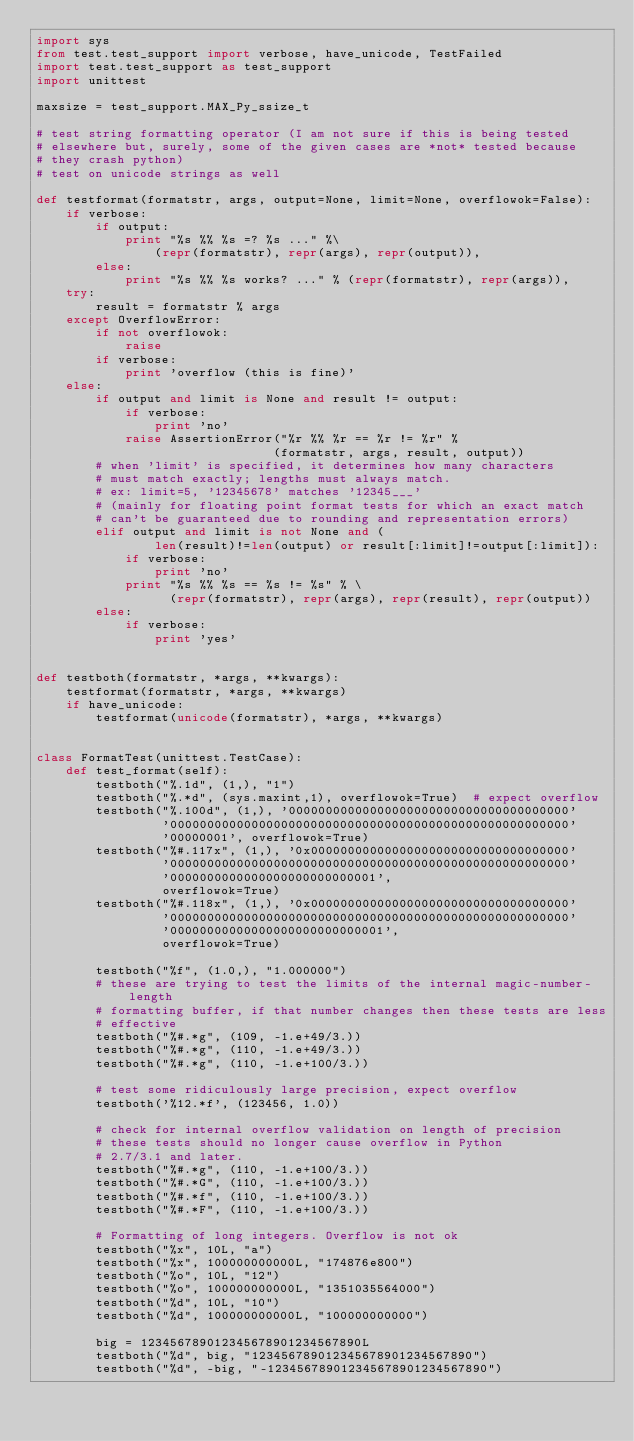Convert code to text. <code><loc_0><loc_0><loc_500><loc_500><_Python_>import sys
from test.test_support import verbose, have_unicode, TestFailed
import test.test_support as test_support
import unittest

maxsize = test_support.MAX_Py_ssize_t

# test string formatting operator (I am not sure if this is being tested
# elsewhere but, surely, some of the given cases are *not* tested because
# they crash python)
# test on unicode strings as well

def testformat(formatstr, args, output=None, limit=None, overflowok=False):
    if verbose:
        if output:
            print "%s %% %s =? %s ..." %\
                (repr(formatstr), repr(args), repr(output)),
        else:
            print "%s %% %s works? ..." % (repr(formatstr), repr(args)),
    try:
        result = formatstr % args
    except OverflowError:
        if not overflowok:
            raise
        if verbose:
            print 'overflow (this is fine)'
    else:
        if output and limit is None and result != output:
            if verbose:
                print 'no'
            raise AssertionError("%r %% %r == %r != %r" %
                                (formatstr, args, result, output))
        # when 'limit' is specified, it determines how many characters
        # must match exactly; lengths must always match.
        # ex: limit=5, '12345678' matches '12345___'
        # (mainly for floating point format tests for which an exact match
        # can't be guaranteed due to rounding and representation errors)
        elif output and limit is not None and (
                len(result)!=len(output) or result[:limit]!=output[:limit]):
            if verbose:
                print 'no'
            print "%s %% %s == %s != %s" % \
                  (repr(formatstr), repr(args), repr(result), repr(output))
        else:
            if verbose:
                print 'yes'


def testboth(formatstr, *args, **kwargs):
    testformat(formatstr, *args, **kwargs)
    if have_unicode:
        testformat(unicode(formatstr), *args, **kwargs)


class FormatTest(unittest.TestCase):
    def test_format(self):
        testboth("%.1d", (1,), "1")
        testboth("%.*d", (sys.maxint,1), overflowok=True)  # expect overflow
        testboth("%.100d", (1,), '00000000000000000000000000000000000000'
                 '000000000000000000000000000000000000000000000000000000'
                 '00000001', overflowok=True)
        testboth("%#.117x", (1,), '0x00000000000000000000000000000000000'
                 '000000000000000000000000000000000000000000000000000000'
                 '0000000000000000000000000001',
                 overflowok=True)
        testboth("%#.118x", (1,), '0x00000000000000000000000000000000000'
                 '000000000000000000000000000000000000000000000000000000'
                 '00000000000000000000000000001',
                 overflowok=True)

        testboth("%f", (1.0,), "1.000000")
        # these are trying to test the limits of the internal magic-number-length
        # formatting buffer, if that number changes then these tests are less
        # effective
        testboth("%#.*g", (109, -1.e+49/3.))
        testboth("%#.*g", (110, -1.e+49/3.))
        testboth("%#.*g", (110, -1.e+100/3.))

        # test some ridiculously large precision, expect overflow
        testboth('%12.*f', (123456, 1.0))

        # check for internal overflow validation on length of precision
        # these tests should no longer cause overflow in Python
        # 2.7/3.1 and later.
        testboth("%#.*g", (110, -1.e+100/3.))
        testboth("%#.*G", (110, -1.e+100/3.))
        testboth("%#.*f", (110, -1.e+100/3.))
        testboth("%#.*F", (110, -1.e+100/3.))

        # Formatting of long integers. Overflow is not ok
        testboth("%x", 10L, "a")
        testboth("%x", 100000000000L, "174876e800")
        testboth("%o", 10L, "12")
        testboth("%o", 100000000000L, "1351035564000")
        testboth("%d", 10L, "10")
        testboth("%d", 100000000000L, "100000000000")

        big = 123456789012345678901234567890L
        testboth("%d", big, "123456789012345678901234567890")
        testboth("%d", -big, "-123456789012345678901234567890")</code> 